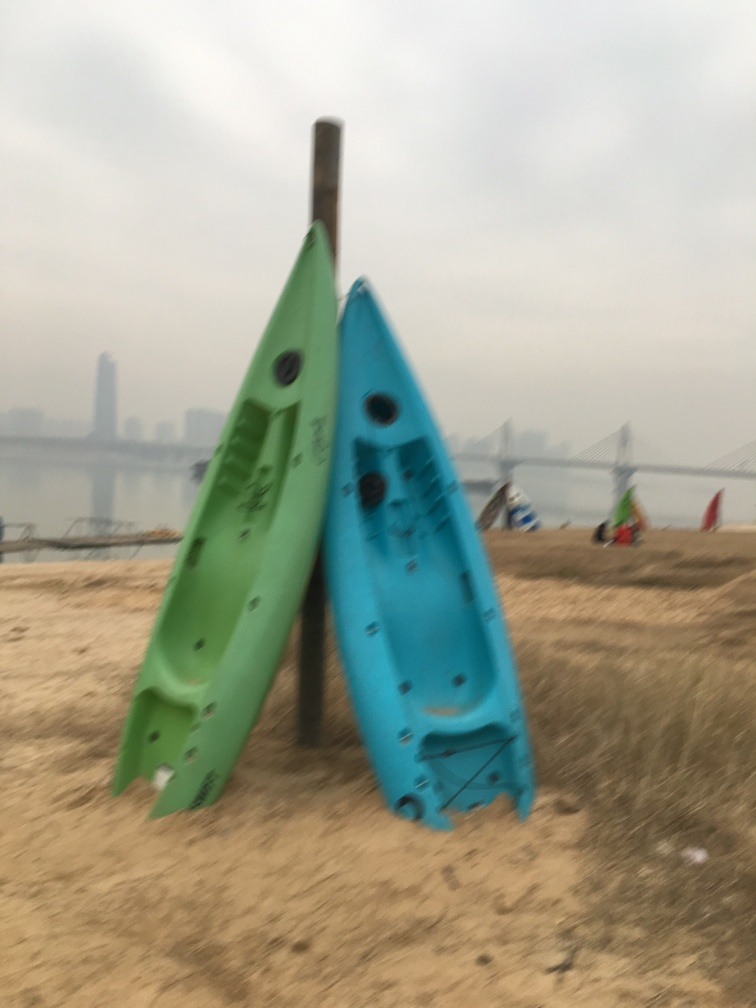Can you comment on the overall composition and its impact on the viewer? The composition places two boats in the foreground, leaning against a pole, which draws the viewer's attention as the main subjects. Their contrasting colors stand out against the muted environment, creating a visual anchor. The background is blurry, which emphasizes the boats and suggests a narrative of abandonment or quietude. The angle of the shot also creates a sense of intimacy with the boats, as the viewer is given a perspective that feels close to the ground. 